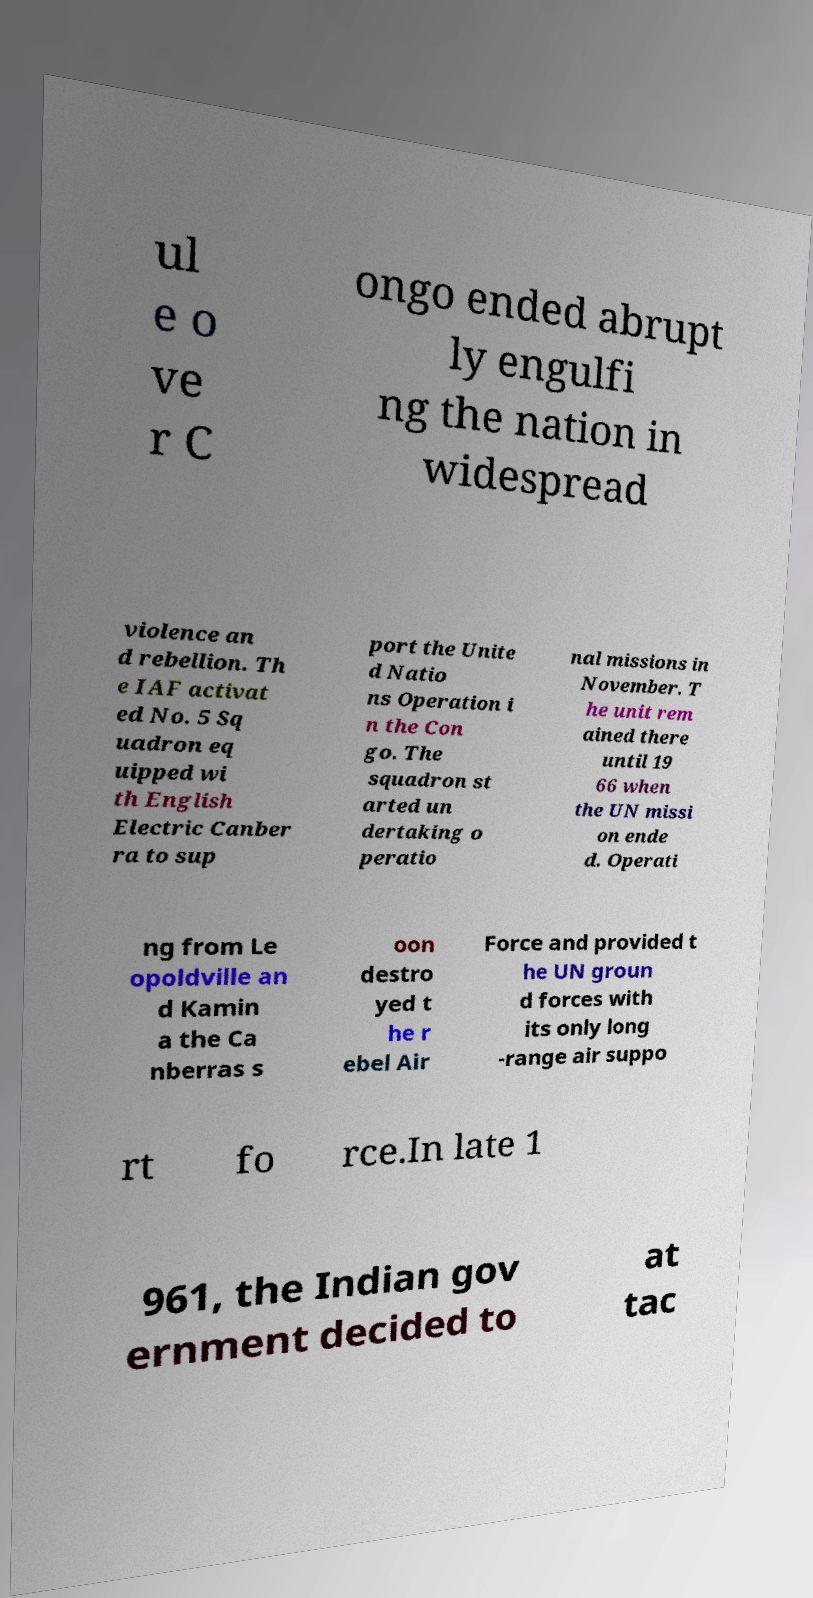Please identify and transcribe the text found in this image. ul e o ve r C ongo ended abrupt ly engulfi ng the nation in widespread violence an d rebellion. Th e IAF activat ed No. 5 Sq uadron eq uipped wi th English Electric Canber ra to sup port the Unite d Natio ns Operation i n the Con go. The squadron st arted un dertaking o peratio nal missions in November. T he unit rem ained there until 19 66 when the UN missi on ende d. Operati ng from Le opoldville an d Kamin a the Ca nberras s oon destro yed t he r ebel Air Force and provided t he UN groun d forces with its only long -range air suppo rt fo rce.In late 1 961, the Indian gov ernment decided to at tac 